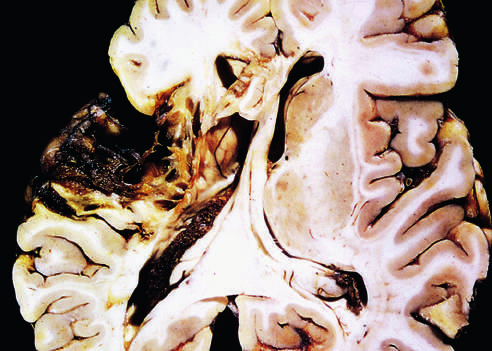what does the old cystic infarct show?
Answer the question using a single word or phrase. Destruction of cortex and surrounding gliosis 